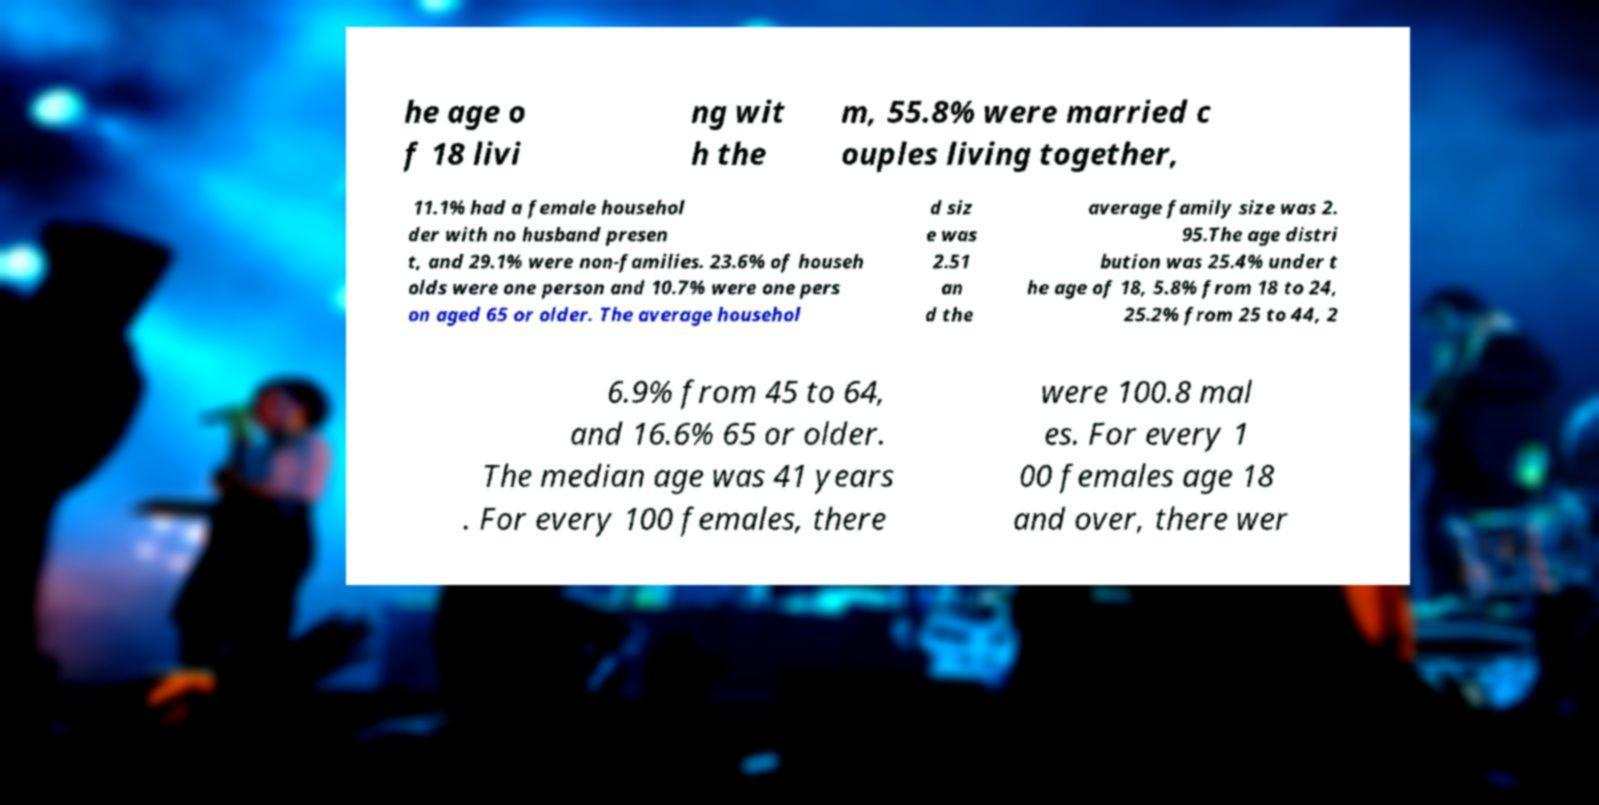Can you read and provide the text displayed in the image?This photo seems to have some interesting text. Can you extract and type it out for me? he age o f 18 livi ng wit h the m, 55.8% were married c ouples living together, 11.1% had a female househol der with no husband presen t, and 29.1% were non-families. 23.6% of househ olds were one person and 10.7% were one pers on aged 65 or older. The average househol d siz e was 2.51 an d the average family size was 2. 95.The age distri bution was 25.4% under t he age of 18, 5.8% from 18 to 24, 25.2% from 25 to 44, 2 6.9% from 45 to 64, and 16.6% 65 or older. The median age was 41 years . For every 100 females, there were 100.8 mal es. For every 1 00 females age 18 and over, there wer 